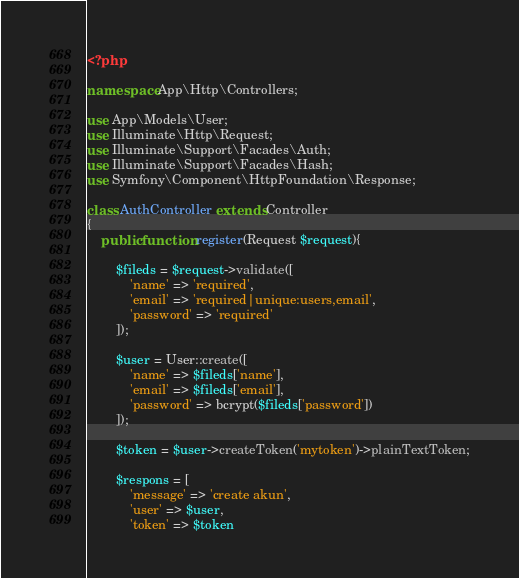Convert code to text. <code><loc_0><loc_0><loc_500><loc_500><_PHP_><?php

namespace App\Http\Controllers;

use App\Models\User;
use Illuminate\Http\Request;
use Illuminate\Support\Facades\Auth;
use Illuminate\Support\Facades\Hash;
use Symfony\Component\HttpFoundation\Response;

class AuthController extends Controller
{
    public function register(Request $request){
        
        $fileds = $request->validate([
            'name' => 'required',
            'email' => 'required|unique:users,email',
            'password' => 'required'
        ]);

        $user = User::create([
            'name' => $fileds['name'],
            'email' => $fileds['email'],
            'password' => bcrypt($fileds['password'])
        ]);

        $token = $user->createToken('mytoken')->plainTextToken;

        $respons = [
            'message' => 'create akun',
            'user' => $user,
            'token' => $token</code> 